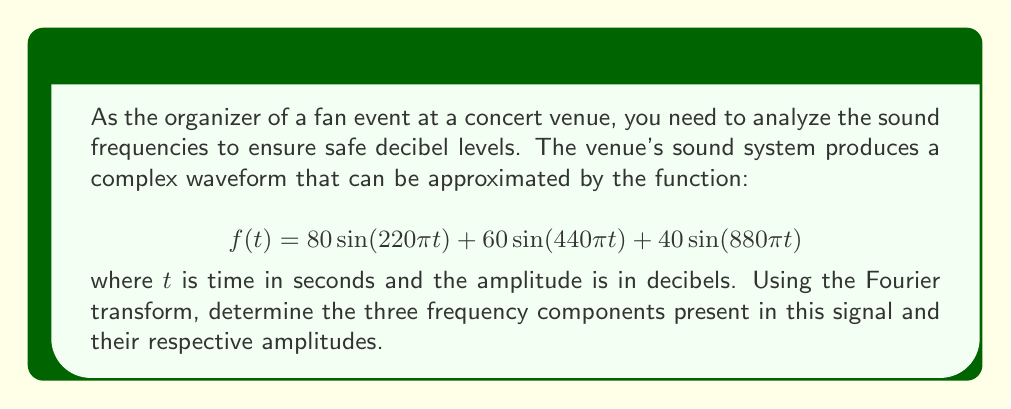Help me with this question. To solve this problem, we need to analyze the given function using the principles of the Fourier transform. The Fourier transform decomposes a signal into its constituent frequencies.

1. The general form of a sinusoidal function is $A\sin(2\pi ft)$, where:
   - $A$ is the amplitude
   - $f$ is the frequency in Hz
   - $t$ is time in seconds

2. Let's break down the given function:

   $$f(t) = 80\sin(220\pi t) + 60\sin(440\pi t) + 40\sin(880\pi t)$$

3. For the first term, $80\sin(220\pi t)$:
   - Amplitude $A_1 = 80$ dB
   - Frequency $f_1 = \frac{220\pi}{2\pi} = 110$ Hz

4. For the second term, $60\sin(440\pi t)$:
   - Amplitude $A_2 = 60$ dB
   - Frequency $f_2 = \frac{440\pi}{2\pi} = 220$ Hz

5. For the third term, $40\sin(880\pi t)$:
   - Amplitude $A_3 = 40$ dB
   - Frequency $f_3 = \frac{880\pi}{2\pi} = 440$ Hz

Therefore, the Fourier transform of this signal reveals three frequency components: 110 Hz, 220 Hz, and 440 Hz, with amplitudes of 80 dB, 60 dB, and 40 dB respectively.
Answer: The three frequency components and their amplitudes are:
1. 110 Hz with an amplitude of 80 dB
2. 220 Hz with an amplitude of 60 dB
3. 440 Hz with an amplitude of 40 dB 